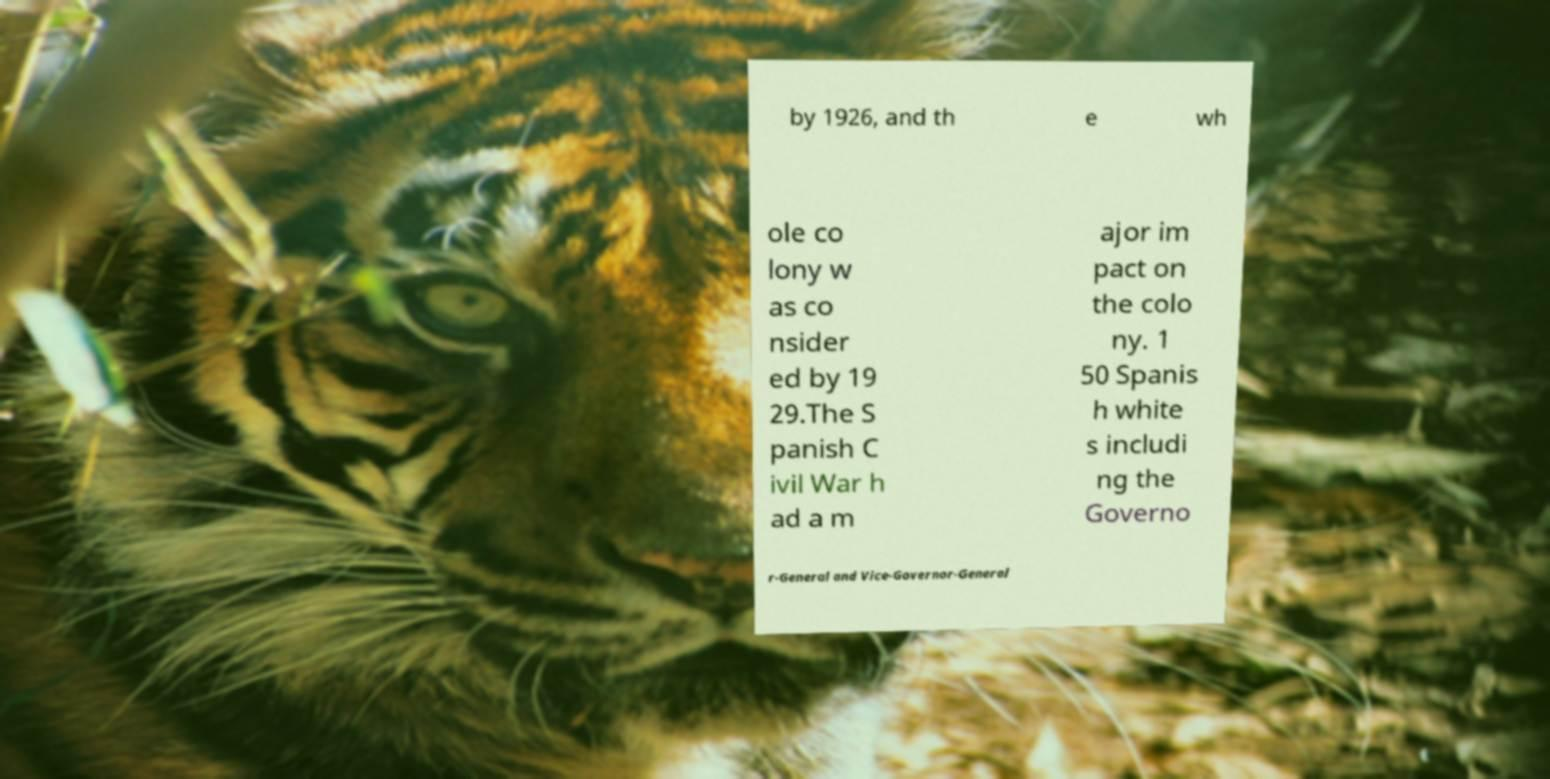There's text embedded in this image that I need extracted. Can you transcribe it verbatim? by 1926, and th e wh ole co lony w as co nsider ed by 19 29.The S panish C ivil War h ad a m ajor im pact on the colo ny. 1 50 Spanis h white s includi ng the Governo r-General and Vice-Governor-General 